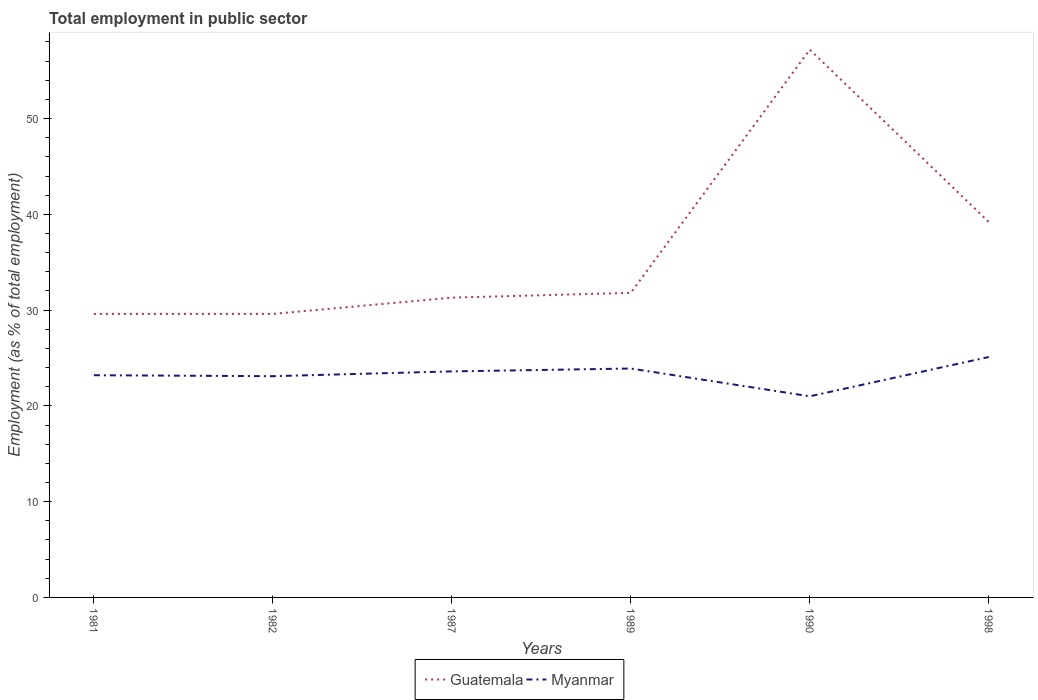In which year was the employment in public sector in Guatemala maximum?
Provide a short and direct response. 1981. What is the difference between the highest and the second highest employment in public sector in Myanmar?
Offer a terse response. 4.1. What is the difference between the highest and the lowest employment in public sector in Guatemala?
Your answer should be compact. 2. How many years are there in the graph?
Provide a short and direct response. 6. Does the graph contain any zero values?
Offer a terse response. No. Where does the legend appear in the graph?
Your answer should be very brief. Bottom center. How many legend labels are there?
Provide a succinct answer. 2. What is the title of the graph?
Your answer should be very brief. Total employment in public sector. What is the label or title of the Y-axis?
Offer a very short reply. Employment (as % of total employment). What is the Employment (as % of total employment) in Guatemala in 1981?
Give a very brief answer. 29.6. What is the Employment (as % of total employment) in Myanmar in 1981?
Provide a short and direct response. 23.2. What is the Employment (as % of total employment) of Guatemala in 1982?
Your answer should be very brief. 29.6. What is the Employment (as % of total employment) in Myanmar in 1982?
Provide a succinct answer. 23.1. What is the Employment (as % of total employment) in Guatemala in 1987?
Offer a terse response. 31.3. What is the Employment (as % of total employment) of Myanmar in 1987?
Give a very brief answer. 23.6. What is the Employment (as % of total employment) of Guatemala in 1989?
Ensure brevity in your answer.  31.8. What is the Employment (as % of total employment) in Myanmar in 1989?
Keep it short and to the point. 23.9. What is the Employment (as % of total employment) of Guatemala in 1990?
Offer a terse response. 57.2. What is the Employment (as % of total employment) in Myanmar in 1990?
Your answer should be very brief. 21. What is the Employment (as % of total employment) of Guatemala in 1998?
Provide a short and direct response. 39.2. What is the Employment (as % of total employment) in Myanmar in 1998?
Your answer should be compact. 25.1. Across all years, what is the maximum Employment (as % of total employment) in Guatemala?
Ensure brevity in your answer.  57.2. Across all years, what is the maximum Employment (as % of total employment) of Myanmar?
Your answer should be very brief. 25.1. Across all years, what is the minimum Employment (as % of total employment) of Guatemala?
Your answer should be very brief. 29.6. Across all years, what is the minimum Employment (as % of total employment) of Myanmar?
Make the answer very short. 21. What is the total Employment (as % of total employment) in Guatemala in the graph?
Your response must be concise. 218.7. What is the total Employment (as % of total employment) of Myanmar in the graph?
Keep it short and to the point. 139.9. What is the difference between the Employment (as % of total employment) of Guatemala in 1981 and that in 1982?
Keep it short and to the point. 0. What is the difference between the Employment (as % of total employment) in Guatemala in 1981 and that in 1987?
Offer a terse response. -1.7. What is the difference between the Employment (as % of total employment) in Myanmar in 1981 and that in 1987?
Offer a terse response. -0.4. What is the difference between the Employment (as % of total employment) in Myanmar in 1981 and that in 1989?
Your answer should be very brief. -0.7. What is the difference between the Employment (as % of total employment) of Guatemala in 1981 and that in 1990?
Your response must be concise. -27.6. What is the difference between the Employment (as % of total employment) in Myanmar in 1981 and that in 1990?
Provide a short and direct response. 2.2. What is the difference between the Employment (as % of total employment) of Guatemala in 1981 and that in 1998?
Your answer should be compact. -9.6. What is the difference between the Employment (as % of total employment) in Myanmar in 1982 and that in 1989?
Make the answer very short. -0.8. What is the difference between the Employment (as % of total employment) in Guatemala in 1982 and that in 1990?
Give a very brief answer. -27.6. What is the difference between the Employment (as % of total employment) in Myanmar in 1982 and that in 1990?
Offer a terse response. 2.1. What is the difference between the Employment (as % of total employment) of Myanmar in 1982 and that in 1998?
Provide a succinct answer. -2. What is the difference between the Employment (as % of total employment) in Guatemala in 1987 and that in 1989?
Provide a short and direct response. -0.5. What is the difference between the Employment (as % of total employment) in Guatemala in 1987 and that in 1990?
Give a very brief answer. -25.9. What is the difference between the Employment (as % of total employment) of Myanmar in 1987 and that in 1998?
Make the answer very short. -1.5. What is the difference between the Employment (as % of total employment) of Guatemala in 1989 and that in 1990?
Your response must be concise. -25.4. What is the difference between the Employment (as % of total employment) in Myanmar in 1989 and that in 1990?
Make the answer very short. 2.9. What is the difference between the Employment (as % of total employment) in Guatemala in 1990 and that in 1998?
Provide a succinct answer. 18. What is the difference between the Employment (as % of total employment) in Guatemala in 1981 and the Employment (as % of total employment) in Myanmar in 1982?
Offer a very short reply. 6.5. What is the difference between the Employment (as % of total employment) of Guatemala in 1981 and the Employment (as % of total employment) of Myanmar in 1989?
Offer a terse response. 5.7. What is the difference between the Employment (as % of total employment) of Guatemala in 1987 and the Employment (as % of total employment) of Myanmar in 1990?
Offer a terse response. 10.3. What is the difference between the Employment (as % of total employment) of Guatemala in 1989 and the Employment (as % of total employment) of Myanmar in 1990?
Give a very brief answer. 10.8. What is the difference between the Employment (as % of total employment) in Guatemala in 1990 and the Employment (as % of total employment) in Myanmar in 1998?
Provide a short and direct response. 32.1. What is the average Employment (as % of total employment) of Guatemala per year?
Keep it short and to the point. 36.45. What is the average Employment (as % of total employment) of Myanmar per year?
Your answer should be very brief. 23.32. In the year 1981, what is the difference between the Employment (as % of total employment) in Guatemala and Employment (as % of total employment) in Myanmar?
Your answer should be very brief. 6.4. In the year 1989, what is the difference between the Employment (as % of total employment) in Guatemala and Employment (as % of total employment) in Myanmar?
Give a very brief answer. 7.9. In the year 1990, what is the difference between the Employment (as % of total employment) of Guatemala and Employment (as % of total employment) of Myanmar?
Give a very brief answer. 36.2. In the year 1998, what is the difference between the Employment (as % of total employment) of Guatemala and Employment (as % of total employment) of Myanmar?
Your answer should be very brief. 14.1. What is the ratio of the Employment (as % of total employment) of Guatemala in 1981 to that in 1982?
Provide a short and direct response. 1. What is the ratio of the Employment (as % of total employment) of Guatemala in 1981 to that in 1987?
Provide a succinct answer. 0.95. What is the ratio of the Employment (as % of total employment) of Myanmar in 1981 to that in 1987?
Offer a very short reply. 0.98. What is the ratio of the Employment (as % of total employment) in Guatemala in 1981 to that in 1989?
Offer a very short reply. 0.93. What is the ratio of the Employment (as % of total employment) of Myanmar in 1981 to that in 1989?
Give a very brief answer. 0.97. What is the ratio of the Employment (as % of total employment) of Guatemala in 1981 to that in 1990?
Provide a short and direct response. 0.52. What is the ratio of the Employment (as % of total employment) of Myanmar in 1981 to that in 1990?
Your answer should be compact. 1.1. What is the ratio of the Employment (as % of total employment) in Guatemala in 1981 to that in 1998?
Make the answer very short. 0.76. What is the ratio of the Employment (as % of total employment) in Myanmar in 1981 to that in 1998?
Your answer should be very brief. 0.92. What is the ratio of the Employment (as % of total employment) of Guatemala in 1982 to that in 1987?
Your response must be concise. 0.95. What is the ratio of the Employment (as % of total employment) in Myanmar in 1982 to that in 1987?
Keep it short and to the point. 0.98. What is the ratio of the Employment (as % of total employment) in Guatemala in 1982 to that in 1989?
Ensure brevity in your answer.  0.93. What is the ratio of the Employment (as % of total employment) of Myanmar in 1982 to that in 1989?
Keep it short and to the point. 0.97. What is the ratio of the Employment (as % of total employment) in Guatemala in 1982 to that in 1990?
Your answer should be very brief. 0.52. What is the ratio of the Employment (as % of total employment) of Guatemala in 1982 to that in 1998?
Provide a succinct answer. 0.76. What is the ratio of the Employment (as % of total employment) of Myanmar in 1982 to that in 1998?
Offer a terse response. 0.92. What is the ratio of the Employment (as % of total employment) in Guatemala in 1987 to that in 1989?
Offer a very short reply. 0.98. What is the ratio of the Employment (as % of total employment) in Myanmar in 1987 to that in 1989?
Keep it short and to the point. 0.99. What is the ratio of the Employment (as % of total employment) of Guatemala in 1987 to that in 1990?
Your answer should be very brief. 0.55. What is the ratio of the Employment (as % of total employment) in Myanmar in 1987 to that in 1990?
Provide a short and direct response. 1.12. What is the ratio of the Employment (as % of total employment) of Guatemala in 1987 to that in 1998?
Give a very brief answer. 0.8. What is the ratio of the Employment (as % of total employment) of Myanmar in 1987 to that in 1998?
Ensure brevity in your answer.  0.94. What is the ratio of the Employment (as % of total employment) of Guatemala in 1989 to that in 1990?
Keep it short and to the point. 0.56. What is the ratio of the Employment (as % of total employment) in Myanmar in 1989 to that in 1990?
Your answer should be compact. 1.14. What is the ratio of the Employment (as % of total employment) of Guatemala in 1989 to that in 1998?
Your answer should be very brief. 0.81. What is the ratio of the Employment (as % of total employment) in Myanmar in 1989 to that in 1998?
Your answer should be compact. 0.95. What is the ratio of the Employment (as % of total employment) in Guatemala in 1990 to that in 1998?
Provide a succinct answer. 1.46. What is the ratio of the Employment (as % of total employment) in Myanmar in 1990 to that in 1998?
Provide a succinct answer. 0.84. What is the difference between the highest and the second highest Employment (as % of total employment) of Guatemala?
Provide a succinct answer. 18. What is the difference between the highest and the second highest Employment (as % of total employment) in Myanmar?
Provide a short and direct response. 1.2. What is the difference between the highest and the lowest Employment (as % of total employment) of Guatemala?
Give a very brief answer. 27.6. 